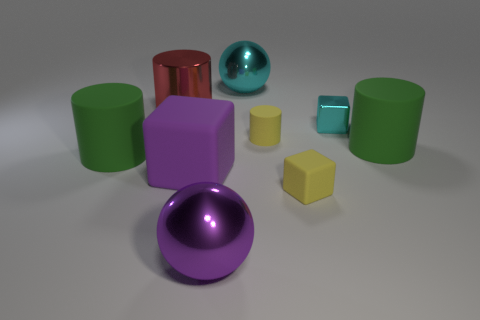Subtract all cyan cylinders. Subtract all gray spheres. How many cylinders are left? 4 Subtract all balls. How many objects are left? 7 Subtract 0 blue blocks. How many objects are left? 9 Subtract all large shiny things. Subtract all small rubber cylinders. How many objects are left? 5 Add 6 large purple balls. How many large purple balls are left? 7 Add 5 purple matte things. How many purple matte things exist? 6 